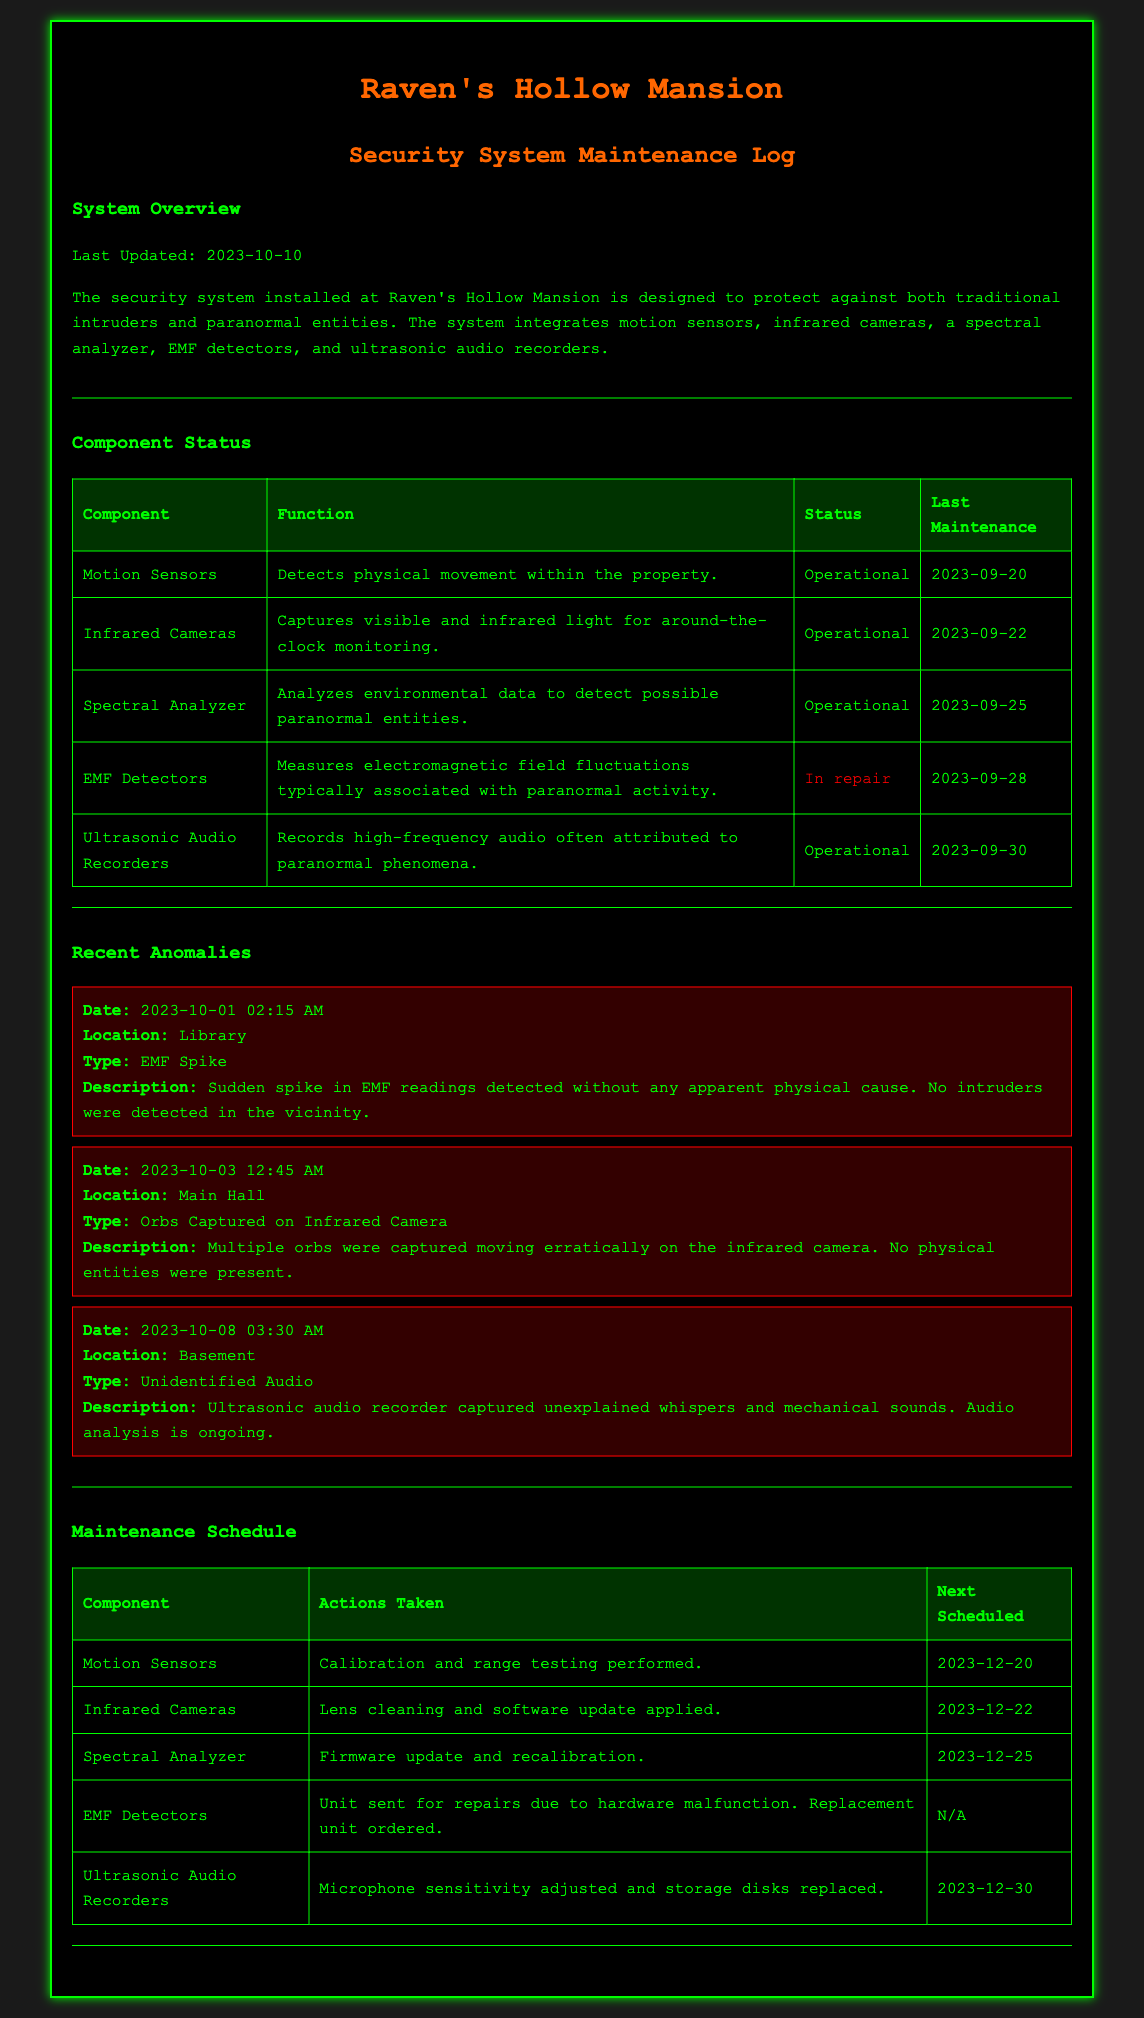what is the last updated date of the security system? The last updated date is stated explicitly in the document and is 2023-10-10.
Answer: 2023-10-10 which component is currently in repair? The document lists the status of each component, stating that the EMF Detectors are in repair.
Answer: EMF Detectors how many anomalies were reported recently? The document presents three separate anomaly reports in the Recent Anomalies section, indicating the count.
Answer: 3 what was the type of the anomaly reported in the Library? The document describes the anomaly in the Library as an EMF Spike.
Answer: EMF Spike when is the next scheduled maintenance for the Infrared Cameras? The document lists future maintenance schedules, showing that the next scheduled maintenance for Infrared Cameras is on 2023-12-22.
Answer: 2023-12-22 which component had a firmware update performed? The document mentions that the Spectral Analyzer had a firmware update and recalibration performed as part of its maintenance.
Answer: Spectral Analyzer what type of anomaly was captured on the infrared camera in the Main Hall? The document specifies that orbs were captured moving erratically on the infrared camera in the Main Hall.
Answer: Orbs Captured on Infrared Camera how many days until the next maintenance for the Motion Sensors from the last updated date? The last updated date is 2023-10-10, and the next scheduled maintenance for the Motion Sensors is on 2023-12-20, which is 71 days away.
Answer: 71 days what kind of tests were performed on the Ultrasonic Audio Recorders? The document details that microphone sensitivity was adjusted and storage disks replaced for the Ultrasonic Audio Recorders.
Answer: Microphone sensitivity adjusted and storage disks replaced 